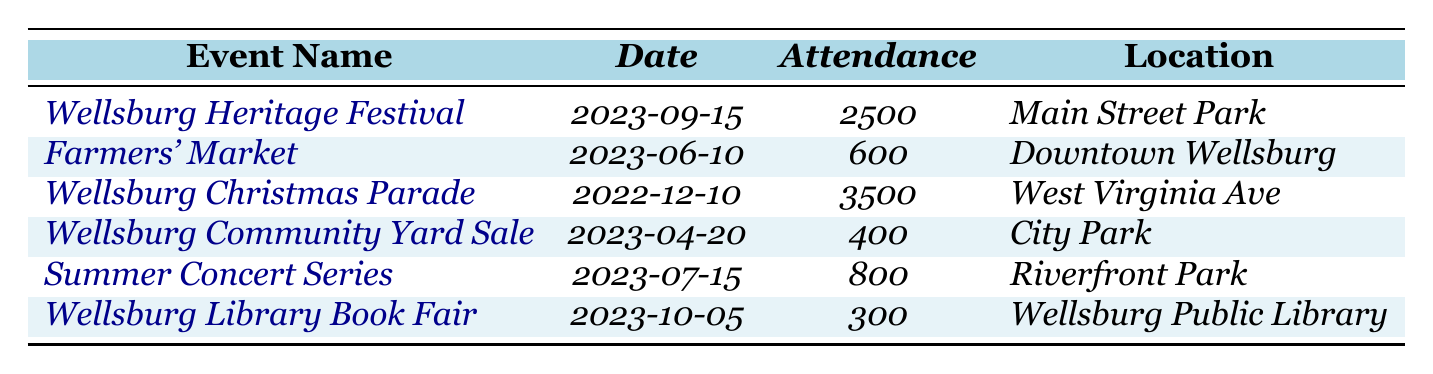What was the attendance at the Wellsburg Heritage Festival? The table shows the attendance for the Wellsburg Heritage Festival listed as 2500.
Answer: 2500 What was the date of the Wellsburg Christmas Parade? The date for the Wellsburg Christmas Parade is stated in the table as 2022-12-10.
Answer: 2022-12-10 Which event had the lowest attendance? Looking through the attendance figures, the Wellsburg Community Yard Sale had the lowest attendance of 400.
Answer: 400 What was the total attendance for all events listed? We add the attendance figures: 2500 + 600 + 3500 + 400 + 800 + 300 = 8300.
Answer: 8300 How many events had attendance above 1000? Only the Wellsburg Heritage Festival (2500) and the Wellsburg Christmas Parade (3500) had attendance figures above 1000. That is 2 events.
Answer: 2 Was the Summer Concert Series held in June? The Summer Concert Series took place on July 15, 2023, not in June.
Answer: No What is the average attendance across all events? We first find the total attendance, which is 8300, and there are 6 events. Thus, the average attendance is 8300 / 6 = 1383.33.
Answer: 1383.33 Which event is scheduled to take place at the Wellsburg Public Library? The event scheduled at the Wellsburg Public Library is the Wellsburg Library Book Fair.
Answer: Wellsburg Library Book Fair Is there any event that took place in the month of April? The table lists the Wellsburg Community Yard Sale, which took place on April 20, 2023.
Answer: Yes What is the difference in attendance between the Wellsburg Heritage Festival and the Christmas Parade? The attendance for the Wellsburg Heritage Festival is 2500 and for the Christmas Parade is 3500. The difference is 3500 - 2500 = 1000.
Answer: 1000 